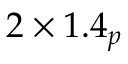Convert formula to latex. <formula><loc_0><loc_0><loc_500><loc_500>2 \times 1 . 4 _ { p }</formula> 